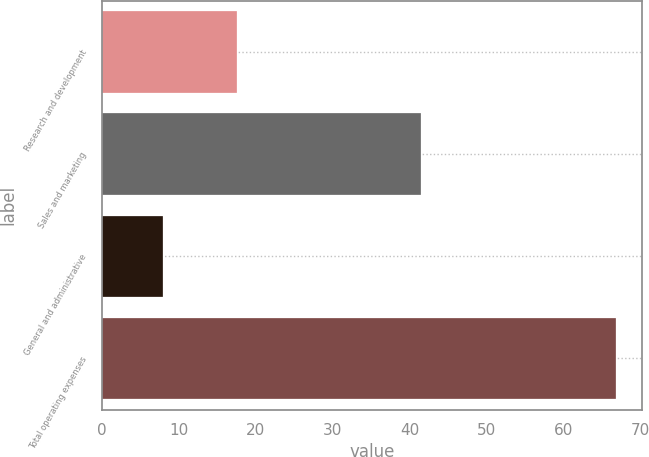Convert chart to OTSL. <chart><loc_0><loc_0><loc_500><loc_500><bar_chart><fcel>Research and development<fcel>Sales and marketing<fcel>General and administrative<fcel>Total operating expenses<nl><fcel>17.5<fcel>41.4<fcel>7.9<fcel>66.8<nl></chart> 